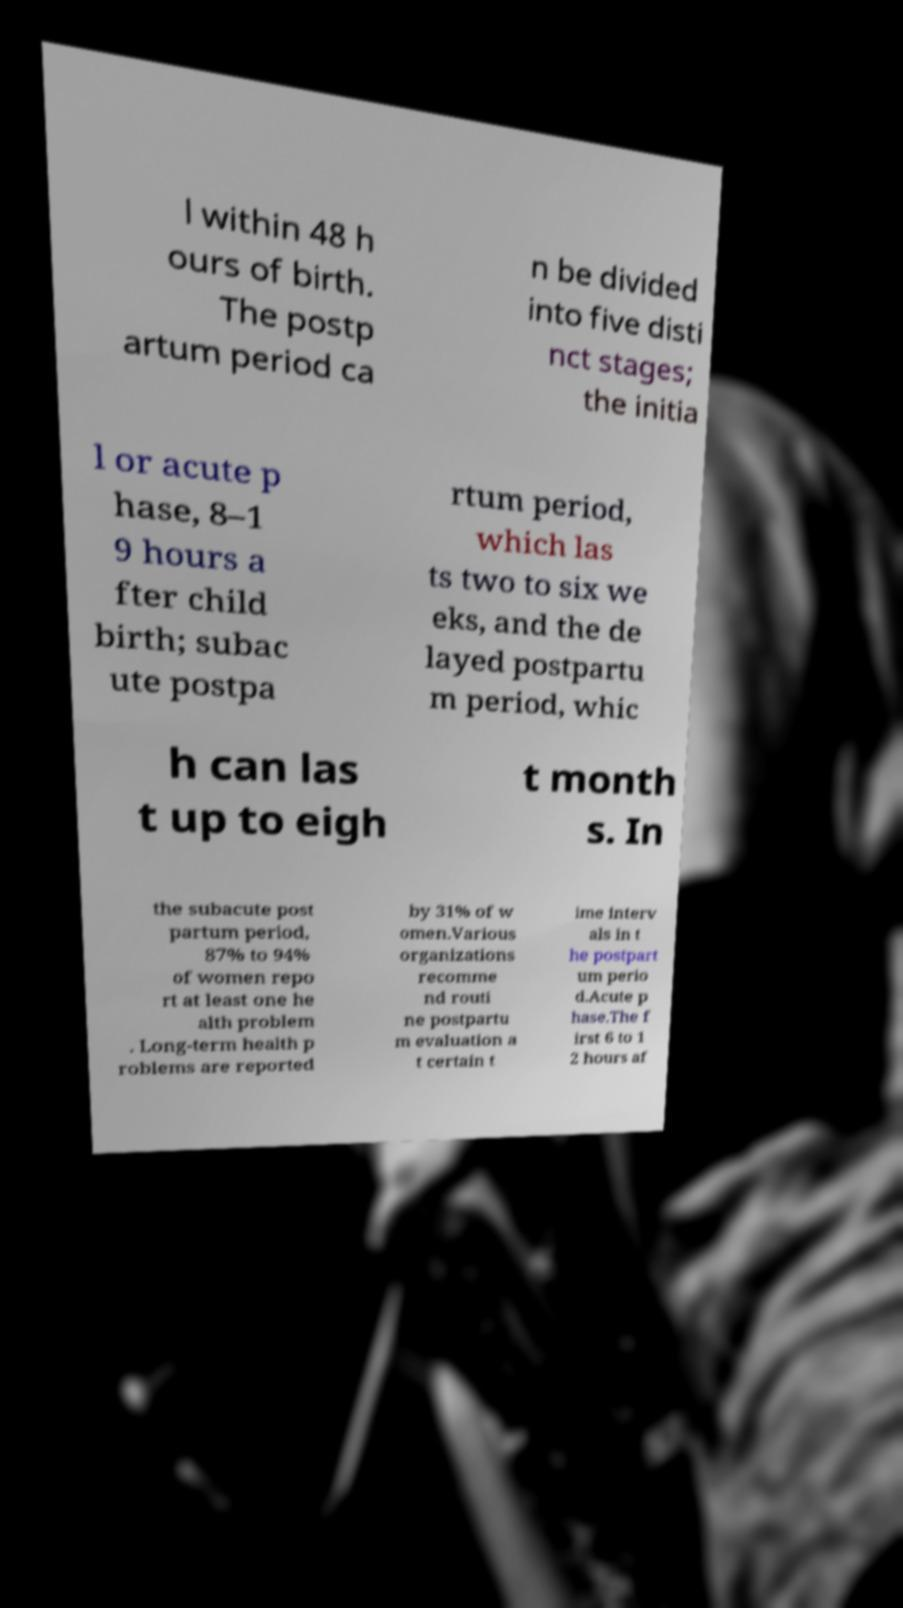Please read and relay the text visible in this image. What does it say? l within 48 h ours of birth. The postp artum period ca n be divided into five disti nct stages; the initia l or acute p hase, 8–1 9 hours a fter child birth; subac ute postpa rtum period, which las ts two to six we eks, and the de layed postpartu m period, whic h can las t up to eigh t month s. In the subacute post partum period, 87% to 94% of women repo rt at least one he alth problem . Long-term health p roblems are reported by 31% of w omen.Various organizations recomme nd routi ne postpartu m evaluation a t certain t ime interv als in t he postpart um perio d.Acute p hase.The f irst 6 to 1 2 hours af 